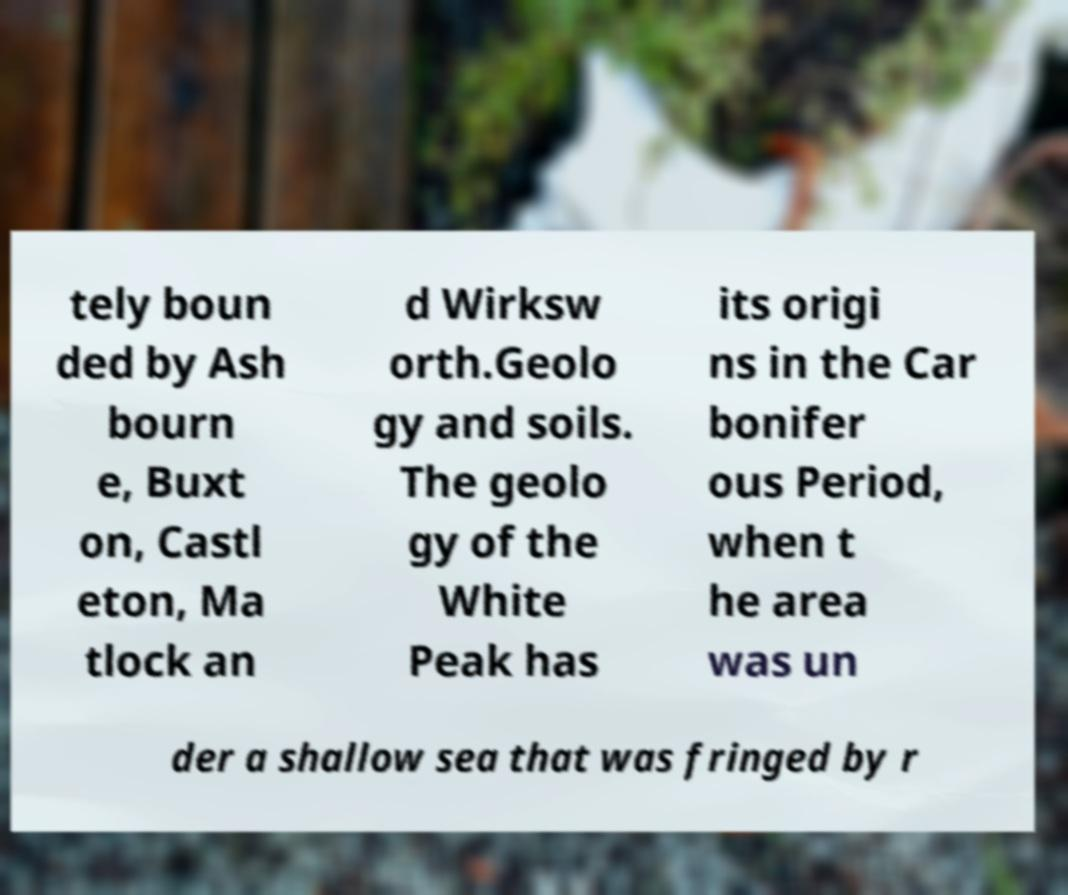What messages or text are displayed in this image? I need them in a readable, typed format. tely boun ded by Ash bourn e, Buxt on, Castl eton, Ma tlock an d Wirksw orth.Geolo gy and soils. The geolo gy of the White Peak has its origi ns in the Car bonifer ous Period, when t he area was un der a shallow sea that was fringed by r 